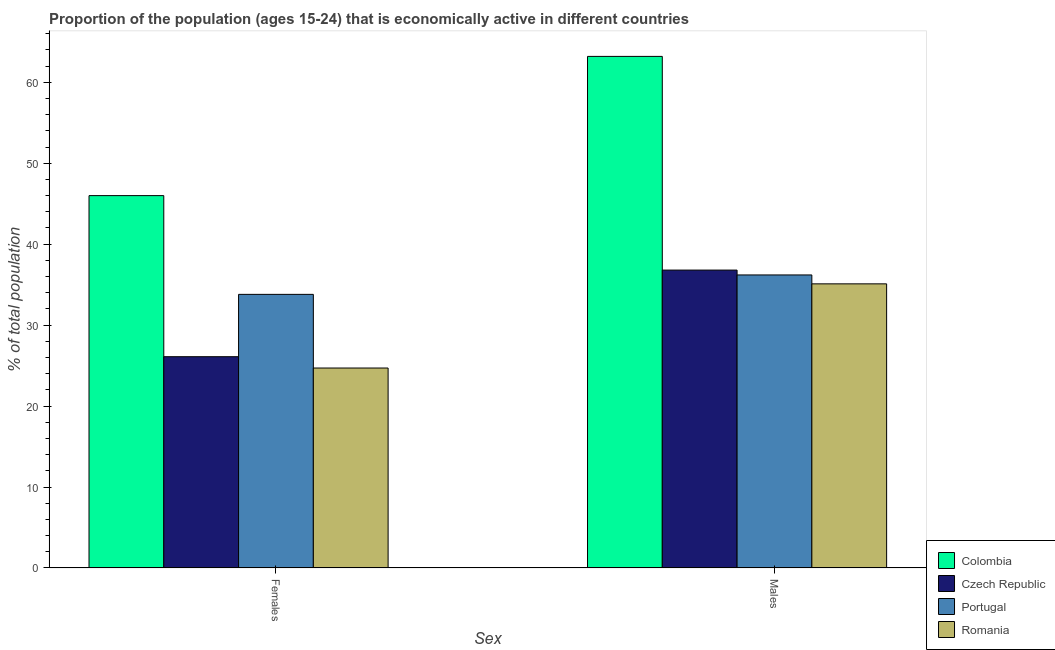How many different coloured bars are there?
Keep it short and to the point. 4. Are the number of bars per tick equal to the number of legend labels?
Ensure brevity in your answer.  Yes. Are the number of bars on each tick of the X-axis equal?
Your answer should be compact. Yes. How many bars are there on the 2nd tick from the right?
Give a very brief answer. 4. What is the label of the 2nd group of bars from the left?
Provide a short and direct response. Males. What is the percentage of economically active female population in Romania?
Ensure brevity in your answer.  24.7. Across all countries, what is the maximum percentage of economically active male population?
Make the answer very short. 63.2. Across all countries, what is the minimum percentage of economically active male population?
Provide a succinct answer. 35.1. In which country was the percentage of economically active female population minimum?
Provide a succinct answer. Romania. What is the total percentage of economically active male population in the graph?
Provide a succinct answer. 171.3. What is the difference between the percentage of economically active male population in Czech Republic and that in Colombia?
Offer a terse response. -26.4. What is the difference between the percentage of economically active female population in Czech Republic and the percentage of economically active male population in Colombia?
Provide a short and direct response. -37.1. What is the average percentage of economically active female population per country?
Offer a terse response. 32.65. What is the difference between the percentage of economically active male population and percentage of economically active female population in Romania?
Provide a short and direct response. 10.4. In how many countries, is the percentage of economically active male population greater than 46 %?
Your response must be concise. 1. What is the ratio of the percentage of economically active female population in Romania to that in Portugal?
Ensure brevity in your answer.  0.73. Is the percentage of economically active male population in Romania less than that in Czech Republic?
Your answer should be very brief. Yes. In how many countries, is the percentage of economically active female population greater than the average percentage of economically active female population taken over all countries?
Your answer should be compact. 2. What does the 4th bar from the left in Females represents?
Keep it short and to the point. Romania. What does the 1st bar from the right in Males represents?
Your answer should be very brief. Romania. How many bars are there?
Offer a terse response. 8. How are the legend labels stacked?
Offer a terse response. Vertical. What is the title of the graph?
Keep it short and to the point. Proportion of the population (ages 15-24) that is economically active in different countries. What is the label or title of the X-axis?
Give a very brief answer. Sex. What is the label or title of the Y-axis?
Give a very brief answer. % of total population. What is the % of total population of Czech Republic in Females?
Your response must be concise. 26.1. What is the % of total population in Portugal in Females?
Keep it short and to the point. 33.8. What is the % of total population in Romania in Females?
Your answer should be very brief. 24.7. What is the % of total population of Colombia in Males?
Provide a short and direct response. 63.2. What is the % of total population of Czech Republic in Males?
Offer a very short reply. 36.8. What is the % of total population in Portugal in Males?
Your answer should be very brief. 36.2. What is the % of total population of Romania in Males?
Keep it short and to the point. 35.1. Across all Sex, what is the maximum % of total population in Colombia?
Your answer should be compact. 63.2. Across all Sex, what is the maximum % of total population in Czech Republic?
Provide a succinct answer. 36.8. Across all Sex, what is the maximum % of total population in Portugal?
Keep it short and to the point. 36.2. Across all Sex, what is the maximum % of total population in Romania?
Offer a very short reply. 35.1. Across all Sex, what is the minimum % of total population in Czech Republic?
Provide a succinct answer. 26.1. Across all Sex, what is the minimum % of total population of Portugal?
Keep it short and to the point. 33.8. Across all Sex, what is the minimum % of total population in Romania?
Ensure brevity in your answer.  24.7. What is the total % of total population of Colombia in the graph?
Provide a short and direct response. 109.2. What is the total % of total population of Czech Republic in the graph?
Your answer should be compact. 62.9. What is the total % of total population of Portugal in the graph?
Your answer should be compact. 70. What is the total % of total population of Romania in the graph?
Offer a very short reply. 59.8. What is the difference between the % of total population in Colombia in Females and that in Males?
Provide a succinct answer. -17.2. What is the difference between the % of total population in Czech Republic in Females and that in Males?
Give a very brief answer. -10.7. What is the difference between the % of total population of Portugal in Females and that in Males?
Offer a very short reply. -2.4. What is the difference between the % of total population of Romania in Females and that in Males?
Your response must be concise. -10.4. What is the difference between the % of total population of Colombia in Females and the % of total population of Czech Republic in Males?
Make the answer very short. 9.2. What is the difference between the % of total population of Colombia in Females and the % of total population of Romania in Males?
Provide a short and direct response. 10.9. What is the difference between the % of total population of Czech Republic in Females and the % of total population of Portugal in Males?
Provide a succinct answer. -10.1. What is the difference between the % of total population in Czech Republic in Females and the % of total population in Romania in Males?
Keep it short and to the point. -9. What is the difference between the % of total population in Portugal in Females and the % of total population in Romania in Males?
Your response must be concise. -1.3. What is the average % of total population in Colombia per Sex?
Your response must be concise. 54.6. What is the average % of total population of Czech Republic per Sex?
Offer a terse response. 31.45. What is the average % of total population of Romania per Sex?
Your answer should be very brief. 29.9. What is the difference between the % of total population of Colombia and % of total population of Portugal in Females?
Your answer should be very brief. 12.2. What is the difference between the % of total population in Colombia and % of total population in Romania in Females?
Ensure brevity in your answer.  21.3. What is the difference between the % of total population of Czech Republic and % of total population of Romania in Females?
Your answer should be very brief. 1.4. What is the difference between the % of total population of Colombia and % of total population of Czech Republic in Males?
Keep it short and to the point. 26.4. What is the difference between the % of total population in Colombia and % of total population in Portugal in Males?
Offer a very short reply. 27. What is the difference between the % of total population of Colombia and % of total population of Romania in Males?
Keep it short and to the point. 28.1. What is the ratio of the % of total population of Colombia in Females to that in Males?
Make the answer very short. 0.73. What is the ratio of the % of total population in Czech Republic in Females to that in Males?
Offer a very short reply. 0.71. What is the ratio of the % of total population of Portugal in Females to that in Males?
Your answer should be very brief. 0.93. What is the ratio of the % of total population in Romania in Females to that in Males?
Give a very brief answer. 0.7. What is the difference between the highest and the second highest % of total population of Colombia?
Provide a short and direct response. 17.2. What is the difference between the highest and the second highest % of total population in Portugal?
Ensure brevity in your answer.  2.4. What is the difference between the highest and the second highest % of total population in Romania?
Keep it short and to the point. 10.4. What is the difference between the highest and the lowest % of total population of Romania?
Your answer should be very brief. 10.4. 